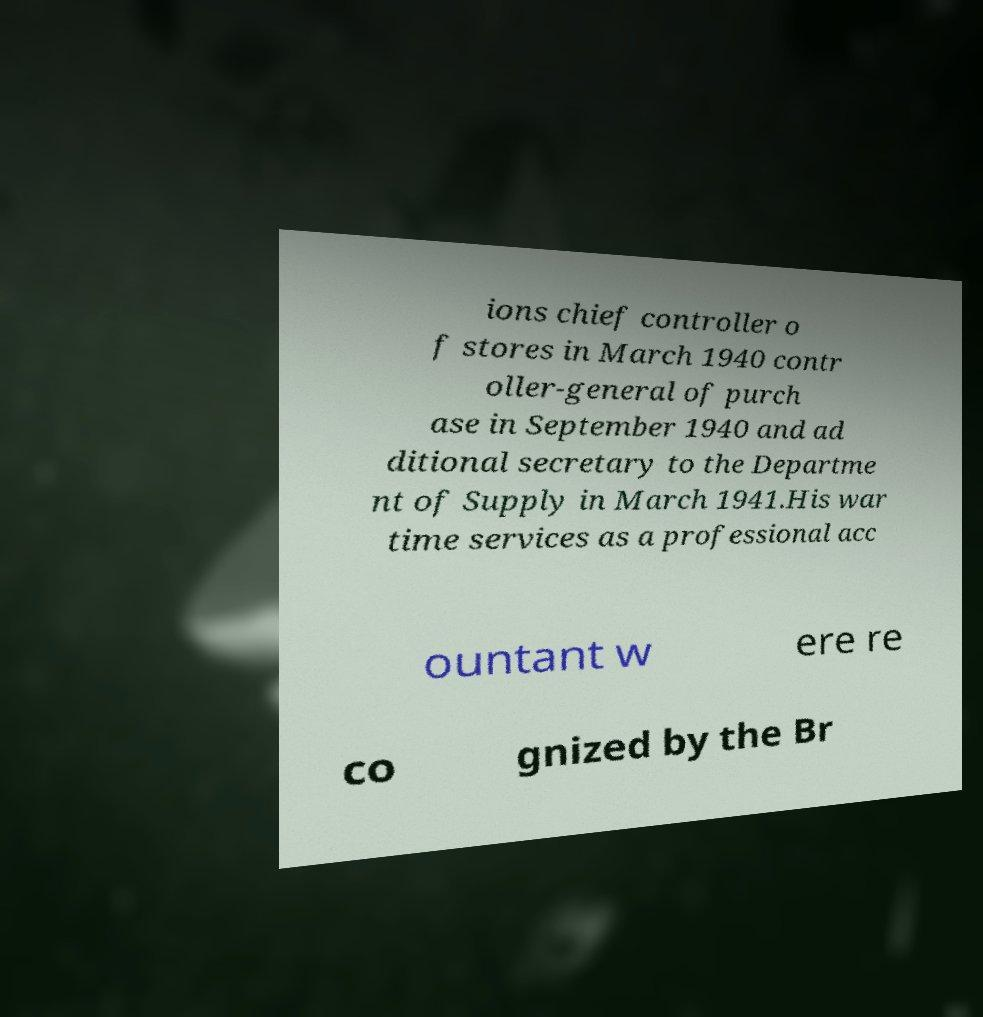There's text embedded in this image that I need extracted. Can you transcribe it verbatim? ions chief controller o f stores in March 1940 contr oller-general of purch ase in September 1940 and ad ditional secretary to the Departme nt of Supply in March 1941.His war time services as a professional acc ountant w ere re co gnized by the Br 